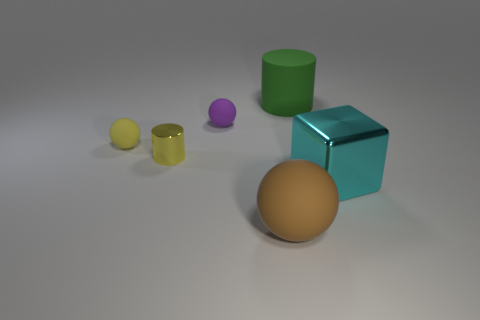Add 2 yellow metal objects. How many objects exist? 8 Subtract all cubes. How many objects are left? 5 Subtract 0 purple cubes. How many objects are left? 6 Subtract all tiny yellow cylinders. Subtract all big cyan metallic cubes. How many objects are left? 4 Add 3 purple spheres. How many purple spheres are left? 4 Add 2 large green matte things. How many large green matte things exist? 3 